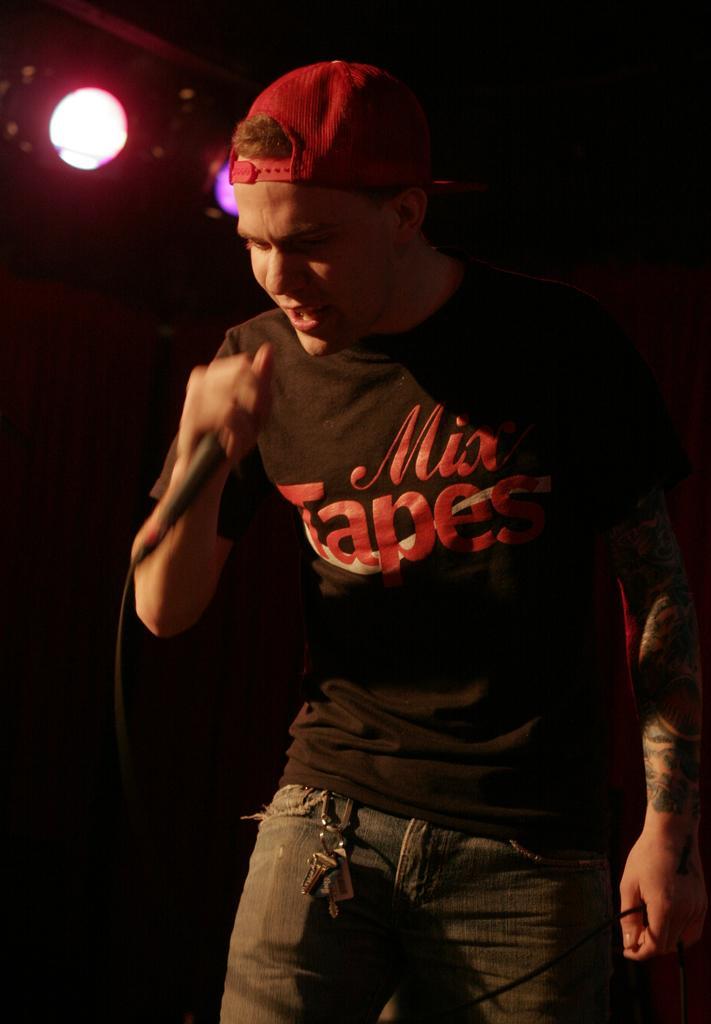In one or two sentences, can you explain what this image depicts? In the image is a man holding a mic and singing and in background there are lights. 